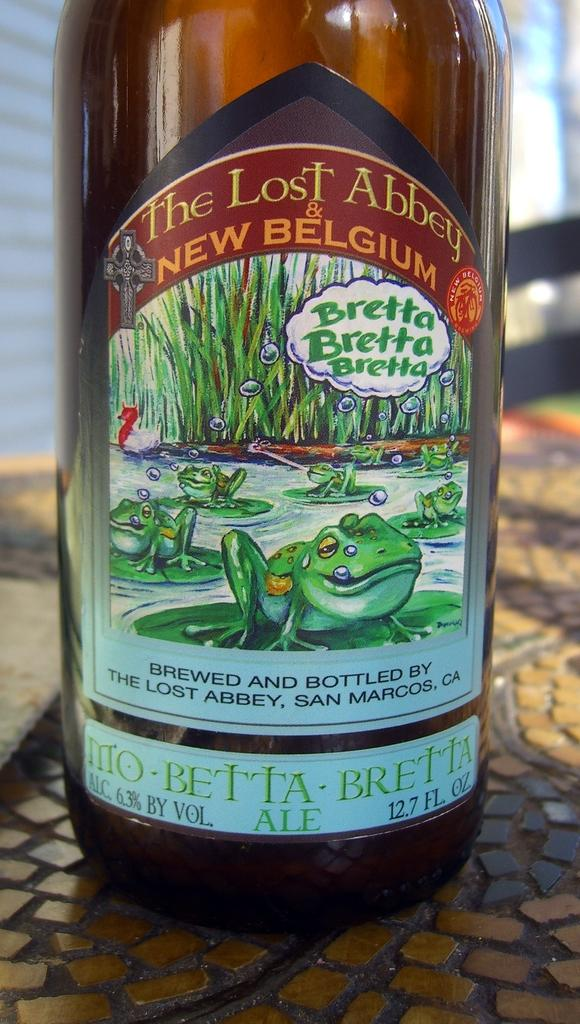Provide a one-sentence caption for the provided image. A bottle of The Lost Abbey New Belgium the label contains various frogs. 